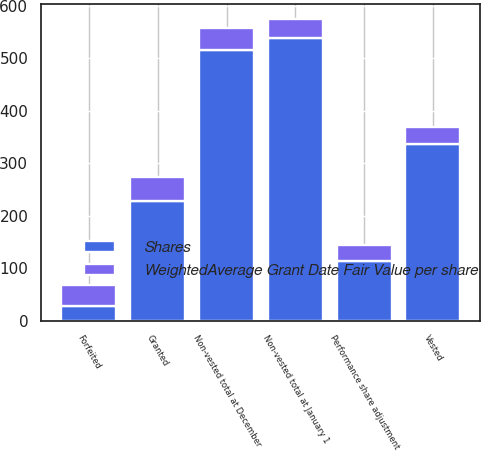Convert chart to OTSL. <chart><loc_0><loc_0><loc_500><loc_500><stacked_bar_chart><ecel><fcel>Non-vested total at January 1<fcel>Granted<fcel>Performance share adjustment<fcel>Vested<fcel>Forfeited<fcel>Non-vested total at December<nl><fcel>Shares<fcel>539<fcel>228<fcel>113<fcel>337<fcel>27<fcel>516<nl><fcel>WeightedAverage Grant Date Fair Value per share<fcel>36.27<fcel>45.45<fcel>30.34<fcel>32.13<fcel>41.61<fcel>41.46<nl></chart> 